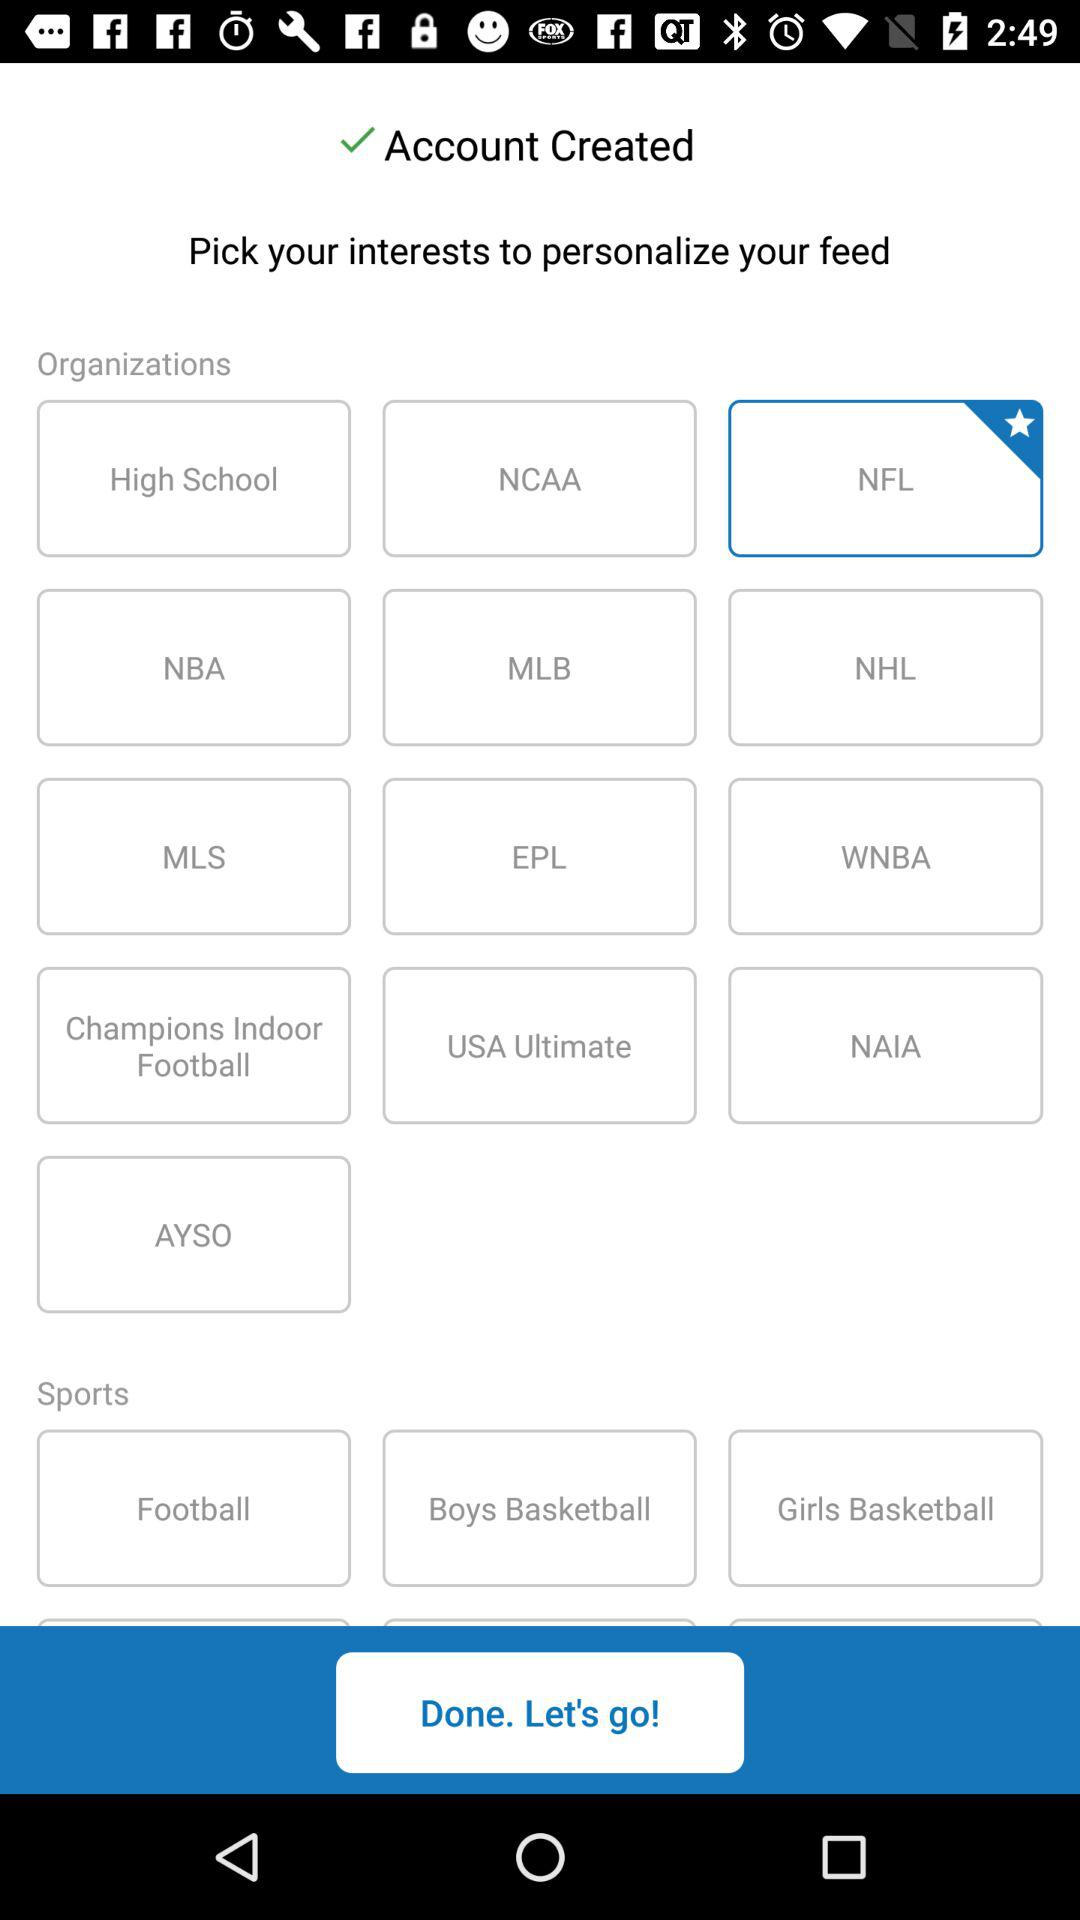Which option is selected in "Sports"?
When the provided information is insufficient, respond with <no answer>. <no answer> 